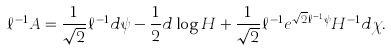<formula> <loc_0><loc_0><loc_500><loc_500>\ell ^ { - 1 } A = { \frac { 1 } { \sqrt { 2 } } } \ell ^ { - 1 } d \psi - { \frac { 1 } { 2 } } d \log H + { \frac { 1 } { \sqrt { 2 } } } \ell ^ { - 1 } e ^ { \sqrt { 2 } \ell ^ { - 1 } \psi } H ^ { - 1 } d \chi .</formula> 